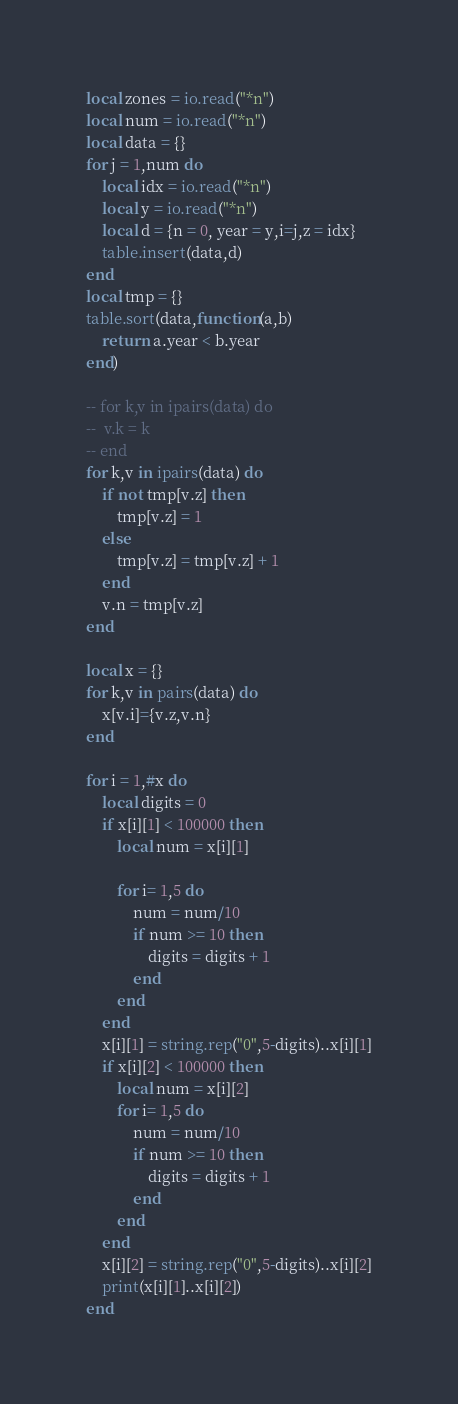<code> <loc_0><loc_0><loc_500><loc_500><_Lua_>local zones = io.read("*n")
local num = io.read("*n")
local data = {}
for j = 1,num do
	local idx = io.read("*n")
	local y = io.read("*n")
	local d = {n = 0, year = y,i=j,z = idx}
	table.insert(data,d)
end
local tmp = {}
table.sort(data,function(a,b)
 	return a.year < b.year
end)

-- for k,v in ipairs(data) do
-- 	v.k = k
-- end
for k,v in ipairs(data) do
	if not tmp[v.z] then
		tmp[v.z] = 1
	else
		tmp[v.z] = tmp[v.z] + 1
	end
	v.n = tmp[v.z]
end

local x = {}
for k,v in pairs(data) do
	x[v.i]={v.z,v.n}
end

for i = 1,#x do
	local digits = 0
	if x[i][1] < 100000 then
		local num = x[i][1]

		for i= 1,5 do
			num = num/10
			if num >= 10 then
				digits = digits + 1
			end
		end
	end
	x[i][1] = string.rep("0",5-digits)..x[i][1]
	if x[i][2] < 100000 then
		local num = x[i][2]
		for i= 1,5 do
			num = num/10
			if num >= 10 then
				digits = digits + 1
			end
		end
	end
	x[i][2] = string.rep("0",5-digits)..x[i][2]
	print(x[i][1]..x[i][2])
end</code> 